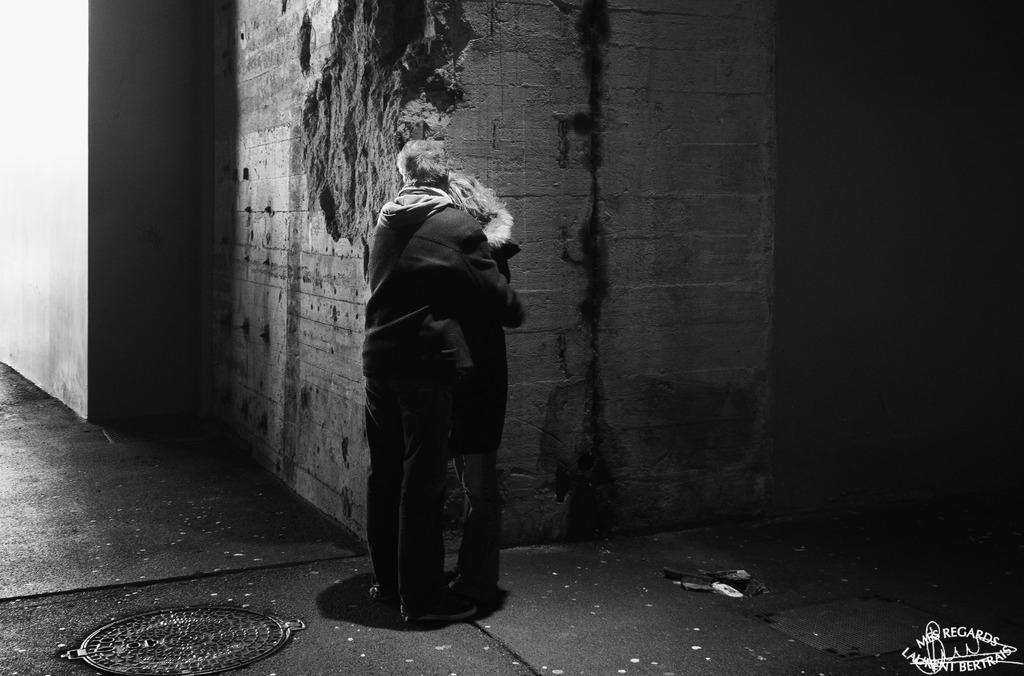Could you give a brief overview of what you see in this image? In this image we can see persons standing on the floor. In the background we can see walls. 